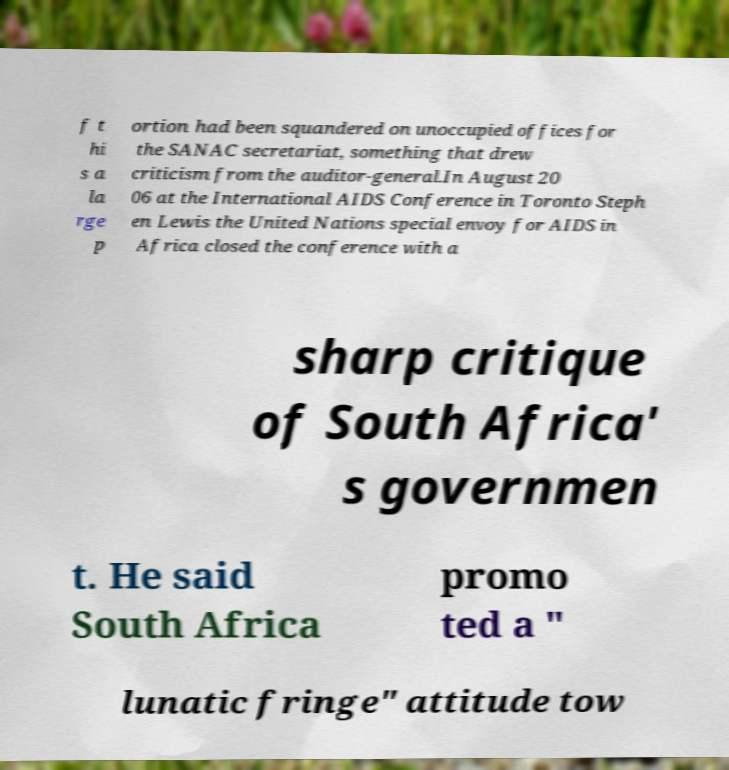Please identify and transcribe the text found in this image. f t hi s a la rge p ortion had been squandered on unoccupied offices for the SANAC secretariat, something that drew criticism from the auditor-general.In August 20 06 at the International AIDS Conference in Toronto Steph en Lewis the United Nations special envoy for AIDS in Africa closed the conference with a sharp critique of South Africa' s governmen t. He said South Africa promo ted a " lunatic fringe" attitude tow 